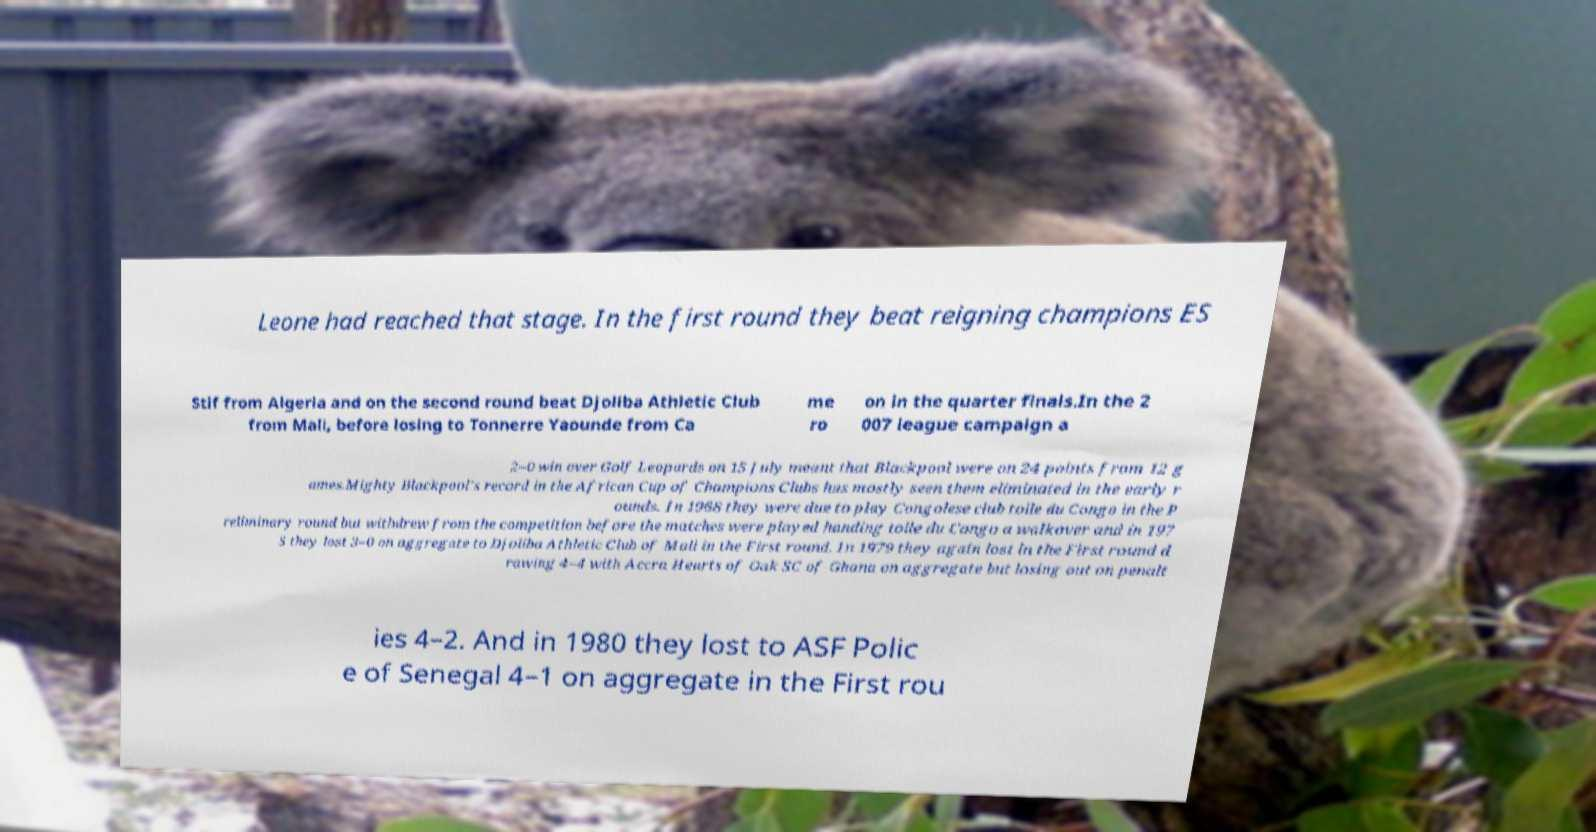What messages or text are displayed in this image? I need them in a readable, typed format. Leone had reached that stage. In the first round they beat reigning champions ES Stif from Algeria and on the second round beat Djoliba Athletic Club from Mali, before losing to Tonnerre Yaounde from Ca me ro on in the quarter finals.In the 2 007 league campaign a 2–0 win over Golf Leopards on 15 July meant that Blackpool were on 24 points from 12 g ames.Mighty Blackpool's record in the African Cup of Champions Clubs has mostly seen them eliminated in the early r ounds. In 1968 they were due to play Congolese club toile du Congo in the P reliminary round but withdrew from the competition before the matches were played handing toile du Congo a walkover and in 197 5 they lost 3–0 on aggregate to Djoliba Athletic Club of Mali in the First round. In 1979 they again lost in the First round d rawing 4–4 with Accra Hearts of Oak SC of Ghana on aggregate but losing out on penalt ies 4–2. And in 1980 they lost to ASF Polic e of Senegal 4–1 on aggregate in the First rou 